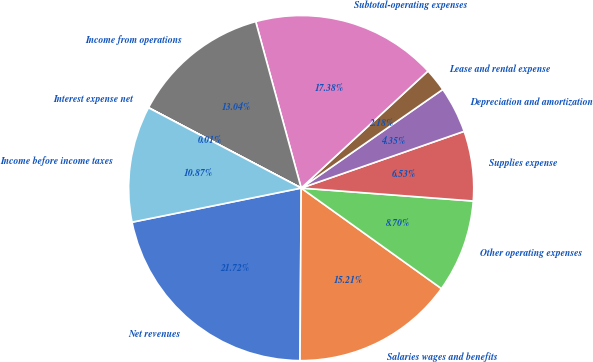Convert chart to OTSL. <chart><loc_0><loc_0><loc_500><loc_500><pie_chart><fcel>Net revenues<fcel>Salaries wages and benefits<fcel>Other operating expenses<fcel>Supplies expense<fcel>Depreciation and amortization<fcel>Lease and rental expense<fcel>Subtotal-operating expenses<fcel>Income from operations<fcel>Interest expense net<fcel>Income before income taxes<nl><fcel>21.72%<fcel>15.21%<fcel>8.7%<fcel>6.53%<fcel>4.35%<fcel>2.18%<fcel>17.38%<fcel>13.04%<fcel>0.01%<fcel>10.87%<nl></chart> 